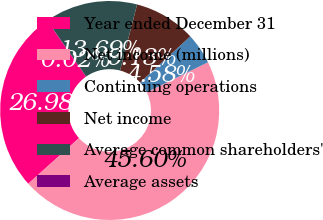Convert chart to OTSL. <chart><loc_0><loc_0><loc_500><loc_500><pie_chart><fcel>Year ended December 31<fcel>Net income (millions)<fcel>Continuing operations<fcel>Net income<fcel>Average common shareholders'<fcel>Average assets<nl><fcel>26.98%<fcel>45.6%<fcel>4.58%<fcel>9.13%<fcel>13.69%<fcel>0.02%<nl></chart> 